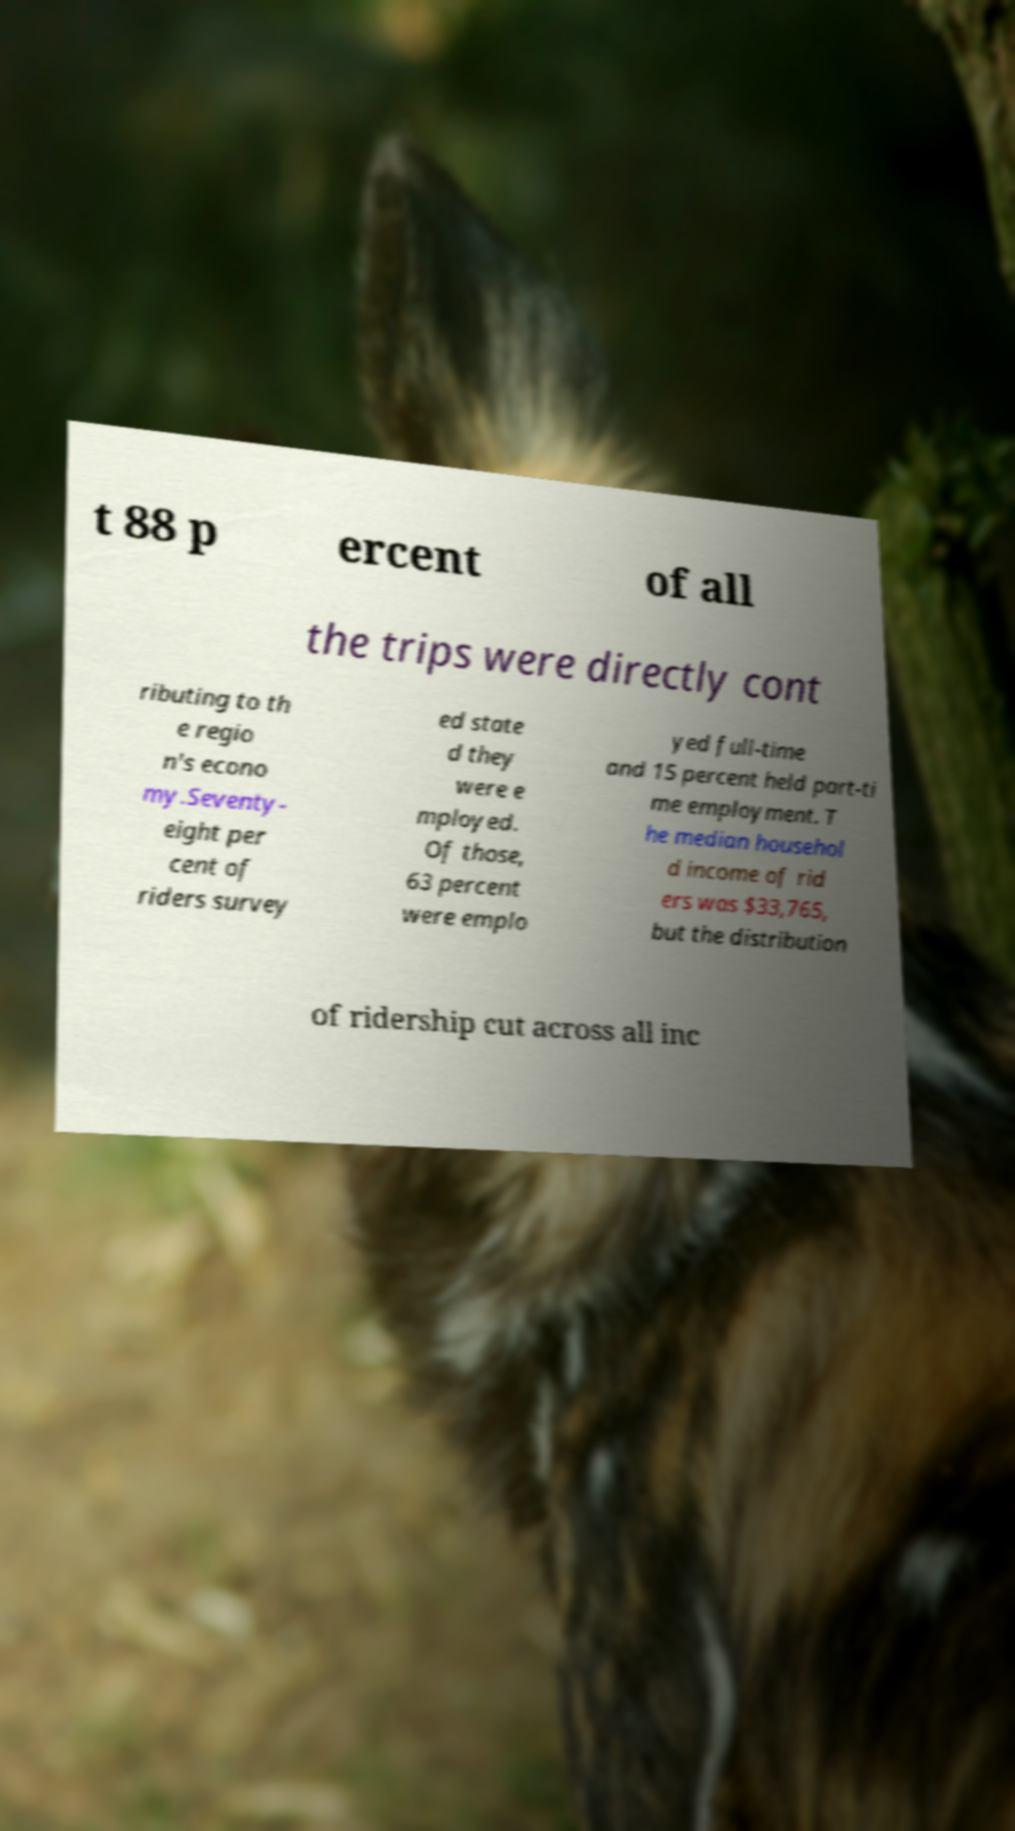Could you assist in decoding the text presented in this image and type it out clearly? t 88 p ercent of all the trips were directly cont ributing to th e regio n's econo my.Seventy- eight per cent of riders survey ed state d they were e mployed. Of those, 63 percent were emplo yed full-time and 15 percent held part-ti me employment. T he median househol d income of rid ers was $33,765, but the distribution of ridership cut across all inc 